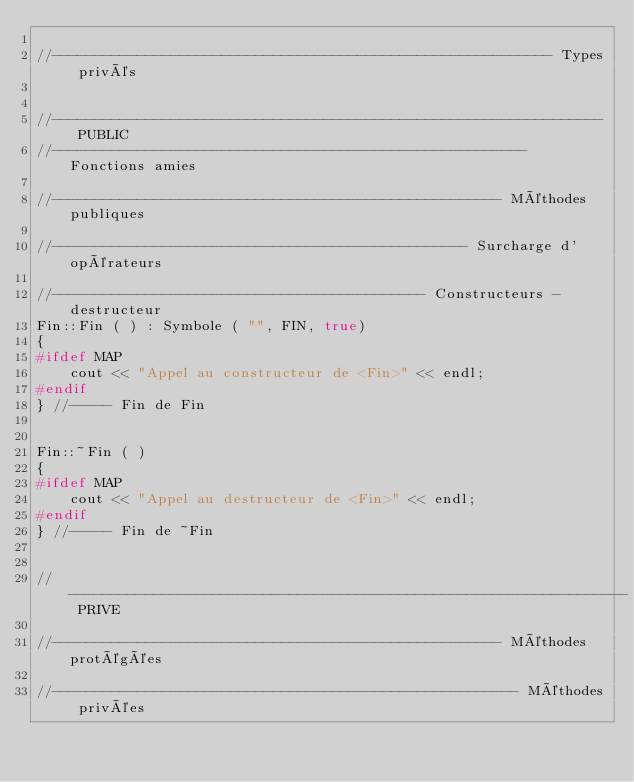<code> <loc_0><loc_0><loc_500><loc_500><_C++_>
//----------------------------------------------------------- Types privés


//----------------------------------------------------------------- PUBLIC
//-------------------------------------------------------- Fonctions amies

//----------------------------------------------------- Méthodes publiques

//------------------------------------------------- Surcharge d'opérateurs

//-------------------------------------------- Constructeurs - destructeur
Fin::Fin ( ) : Symbole ( "", FIN, true)
{
#ifdef MAP
    cout << "Appel au constructeur de <Fin>" << endl;
#endif
} //----- Fin de Fin


Fin::~Fin ( )
{
#ifdef MAP
    cout << "Appel au destructeur de <Fin>" << endl;
#endif
} //----- Fin de ~Fin


//------------------------------------------------------------------ PRIVE

//----------------------------------------------------- Méthodes protégées

//------------------------------------------------------- Méthodes privées
</code> 